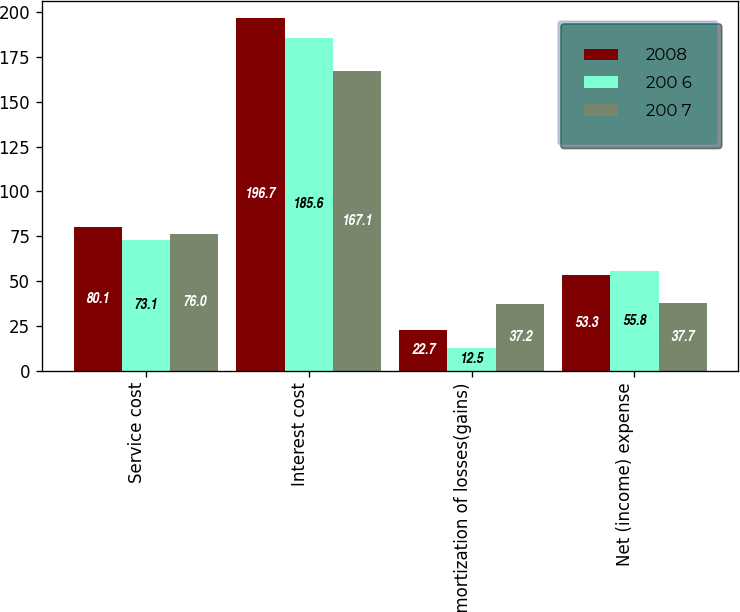Convert chart. <chart><loc_0><loc_0><loc_500><loc_500><stacked_bar_chart><ecel><fcel>Service cost<fcel>Interest cost<fcel>Amortization of losses(gains)<fcel>Net (income) expense<nl><fcel>2008<fcel>80.1<fcel>196.7<fcel>22.7<fcel>53.3<nl><fcel>200 6<fcel>73.1<fcel>185.6<fcel>12.5<fcel>55.8<nl><fcel>200 7<fcel>76<fcel>167.1<fcel>37.2<fcel>37.7<nl></chart> 